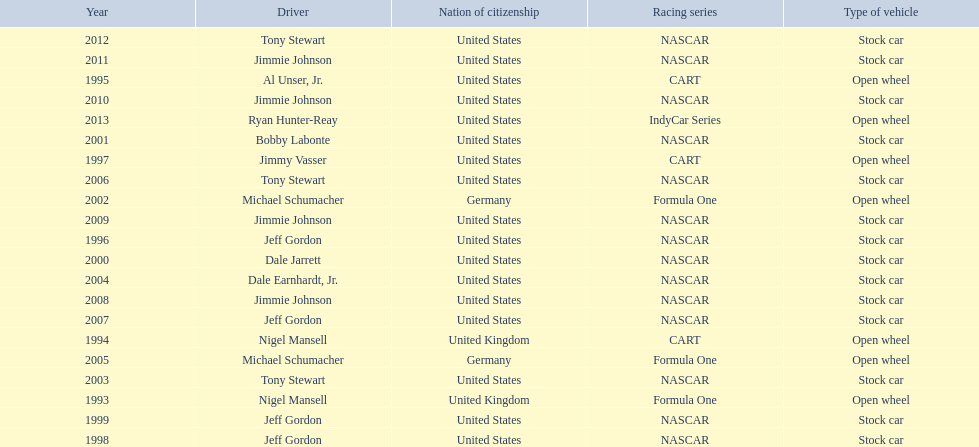Besides nascar, what other racing series have espy-winning drivers come from? Formula One, CART, IndyCar Series. 